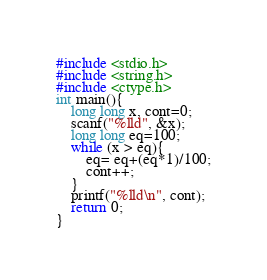<code> <loc_0><loc_0><loc_500><loc_500><_C_>#include <stdio.h>
#include <string.h>
#include <ctype.h>
int main(){
    long long x, cont=0;
    scanf("%lld", &x);
    long long eq=100;
    while (x > eq){
        eq= eq+(eq*1)/100;
        cont++;
    }
    printf("%lld\n", cont);
    return 0;
}</code> 